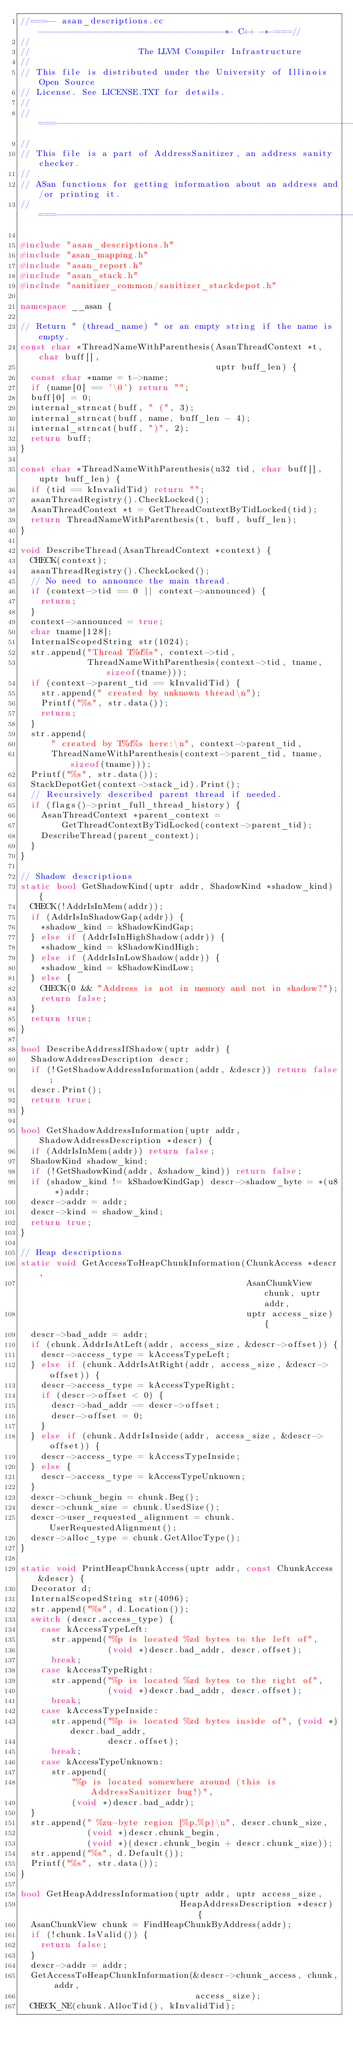Convert code to text. <code><loc_0><loc_0><loc_500><loc_500><_C++_>//===-- asan_descriptions.cc ------------------------------------*- C++ -*-===//
//
//                     The LLVM Compiler Infrastructure
//
// This file is distributed under the University of Illinois Open Source
// License. See LICENSE.TXT for details.
//
//===----------------------------------------------------------------------===//
//
// This file is a part of AddressSanitizer, an address sanity checker.
//
// ASan functions for getting information about an address and/or printing it.
//===----------------------------------------------------------------------===//

#include "asan_descriptions.h"
#include "asan_mapping.h"
#include "asan_report.h"
#include "asan_stack.h"
#include "sanitizer_common/sanitizer_stackdepot.h"

namespace __asan {

// Return " (thread_name) " or an empty string if the name is empty.
const char *ThreadNameWithParenthesis(AsanThreadContext *t, char buff[],
                                      uptr buff_len) {
  const char *name = t->name;
  if (name[0] == '\0') return "";
  buff[0] = 0;
  internal_strncat(buff, " (", 3);
  internal_strncat(buff, name, buff_len - 4);
  internal_strncat(buff, ")", 2);
  return buff;
}

const char *ThreadNameWithParenthesis(u32 tid, char buff[], uptr buff_len) {
  if (tid == kInvalidTid) return "";
  asanThreadRegistry().CheckLocked();
  AsanThreadContext *t = GetThreadContextByTidLocked(tid);
  return ThreadNameWithParenthesis(t, buff, buff_len);
}

void DescribeThread(AsanThreadContext *context) {
  CHECK(context);
  asanThreadRegistry().CheckLocked();
  // No need to announce the main thread.
  if (context->tid == 0 || context->announced) {
    return;
  }
  context->announced = true;
  char tname[128];
  InternalScopedString str(1024);
  str.append("Thread T%d%s", context->tid,
             ThreadNameWithParenthesis(context->tid, tname, sizeof(tname)));
  if (context->parent_tid == kInvalidTid) {
    str.append(" created by unknown thread\n");
    Printf("%s", str.data());
    return;
  }
  str.append(
      " created by T%d%s here:\n", context->parent_tid,
      ThreadNameWithParenthesis(context->parent_tid, tname, sizeof(tname)));
  Printf("%s", str.data());
  StackDepotGet(context->stack_id).Print();
  // Recursively described parent thread if needed.
  if (flags()->print_full_thread_history) {
    AsanThreadContext *parent_context =
        GetThreadContextByTidLocked(context->parent_tid);
    DescribeThread(parent_context);
  }
}

// Shadow descriptions
static bool GetShadowKind(uptr addr, ShadowKind *shadow_kind) {
  CHECK(!AddrIsInMem(addr));
  if (AddrIsInShadowGap(addr)) {
    *shadow_kind = kShadowKindGap;
  } else if (AddrIsInHighShadow(addr)) {
    *shadow_kind = kShadowKindHigh;
  } else if (AddrIsInLowShadow(addr)) {
    *shadow_kind = kShadowKindLow;
  } else {
    CHECK(0 && "Address is not in memory and not in shadow?");
    return false;
  }
  return true;
}

bool DescribeAddressIfShadow(uptr addr) {
  ShadowAddressDescription descr;
  if (!GetShadowAddressInformation(addr, &descr)) return false;
  descr.Print();
  return true;
}

bool GetShadowAddressInformation(uptr addr, ShadowAddressDescription *descr) {
  if (AddrIsInMem(addr)) return false;
  ShadowKind shadow_kind;
  if (!GetShadowKind(addr, &shadow_kind)) return false;
  if (shadow_kind != kShadowKindGap) descr->shadow_byte = *(u8 *)addr;
  descr->addr = addr;
  descr->kind = shadow_kind;
  return true;
}

// Heap descriptions
static void GetAccessToHeapChunkInformation(ChunkAccess *descr,
                                            AsanChunkView chunk, uptr addr,
                                            uptr access_size) {
  descr->bad_addr = addr;
  if (chunk.AddrIsAtLeft(addr, access_size, &descr->offset)) {
    descr->access_type = kAccessTypeLeft;
  } else if (chunk.AddrIsAtRight(addr, access_size, &descr->offset)) {
    descr->access_type = kAccessTypeRight;
    if (descr->offset < 0) {
      descr->bad_addr -= descr->offset;
      descr->offset = 0;
    }
  } else if (chunk.AddrIsInside(addr, access_size, &descr->offset)) {
    descr->access_type = kAccessTypeInside;
  } else {
    descr->access_type = kAccessTypeUnknown;
  }
  descr->chunk_begin = chunk.Beg();
  descr->chunk_size = chunk.UsedSize();
  descr->user_requested_alignment = chunk.UserRequestedAlignment();
  descr->alloc_type = chunk.GetAllocType();
}

static void PrintHeapChunkAccess(uptr addr, const ChunkAccess &descr) {
  Decorator d;
  InternalScopedString str(4096);
  str.append("%s", d.Location());
  switch (descr.access_type) {
    case kAccessTypeLeft:
      str.append("%p is located %zd bytes to the left of",
                 (void *)descr.bad_addr, descr.offset);
      break;
    case kAccessTypeRight:
      str.append("%p is located %zd bytes to the right of",
                 (void *)descr.bad_addr, descr.offset);
      break;
    case kAccessTypeInside:
      str.append("%p is located %zd bytes inside of", (void *)descr.bad_addr,
                 descr.offset);
      break;
    case kAccessTypeUnknown:
      str.append(
          "%p is located somewhere around (this is AddressSanitizer bug!)",
          (void *)descr.bad_addr);
  }
  str.append(" %zu-byte region [%p,%p)\n", descr.chunk_size,
             (void *)descr.chunk_begin,
             (void *)(descr.chunk_begin + descr.chunk_size));
  str.append("%s", d.Default());
  Printf("%s", str.data());
}

bool GetHeapAddressInformation(uptr addr, uptr access_size,
                               HeapAddressDescription *descr) {
  AsanChunkView chunk = FindHeapChunkByAddress(addr);
  if (!chunk.IsValid()) {
    return false;
  }
  descr->addr = addr;
  GetAccessToHeapChunkInformation(&descr->chunk_access, chunk, addr,
                                  access_size);
  CHECK_NE(chunk.AllocTid(), kInvalidTid);</code> 